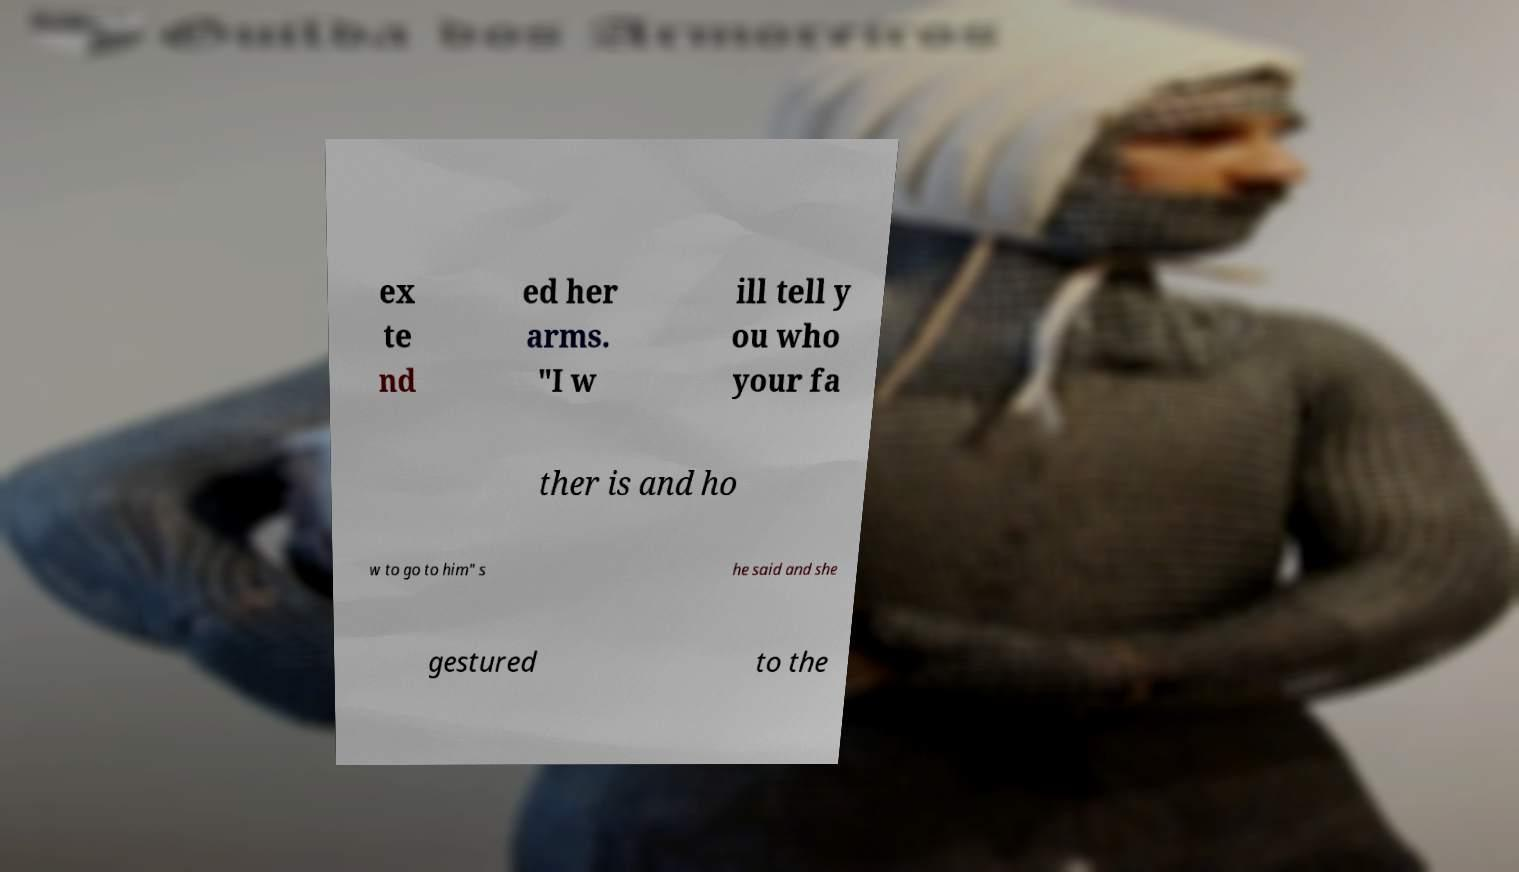I need the written content from this picture converted into text. Can you do that? ex te nd ed her arms. "I w ill tell y ou who your fa ther is and ho w to go to him" s he said and she gestured to the 